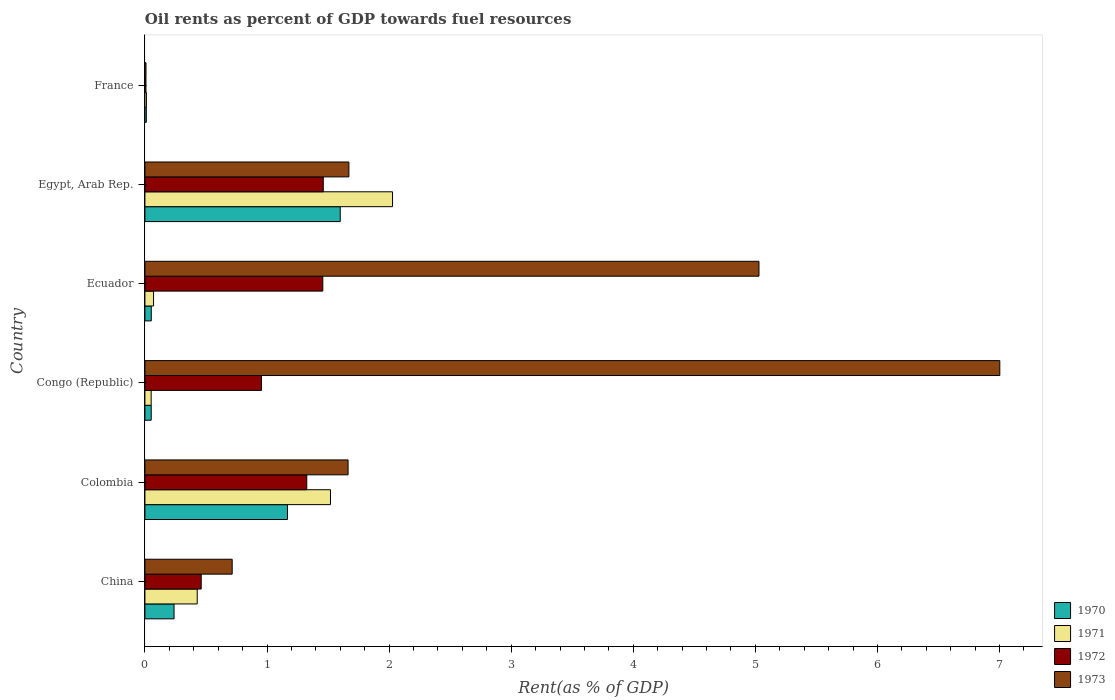How many bars are there on the 1st tick from the bottom?
Provide a short and direct response. 4. What is the oil rent in 1971 in Ecuador?
Your answer should be compact. 0.07. Across all countries, what is the maximum oil rent in 1973?
Give a very brief answer. 7. Across all countries, what is the minimum oil rent in 1970?
Offer a very short reply. 0.01. In which country was the oil rent in 1973 maximum?
Ensure brevity in your answer.  Congo (Republic). What is the total oil rent in 1971 in the graph?
Your answer should be very brief. 4.11. What is the difference between the oil rent in 1971 in China and that in France?
Provide a succinct answer. 0.42. What is the difference between the oil rent in 1972 in Egypt, Arab Rep. and the oil rent in 1973 in Ecuador?
Provide a succinct answer. -3.57. What is the average oil rent in 1972 per country?
Your response must be concise. 0.94. What is the difference between the oil rent in 1973 and oil rent in 1971 in France?
Offer a terse response. -0. In how many countries, is the oil rent in 1972 greater than 3.6 %?
Offer a very short reply. 0. What is the ratio of the oil rent in 1971 in China to that in Egypt, Arab Rep.?
Keep it short and to the point. 0.21. Is the oil rent in 1973 in China less than that in Egypt, Arab Rep.?
Offer a very short reply. Yes. Is the difference between the oil rent in 1973 in China and Egypt, Arab Rep. greater than the difference between the oil rent in 1971 in China and Egypt, Arab Rep.?
Make the answer very short. Yes. What is the difference between the highest and the second highest oil rent in 1970?
Your answer should be compact. 0.43. What is the difference between the highest and the lowest oil rent in 1971?
Your answer should be compact. 2.02. In how many countries, is the oil rent in 1970 greater than the average oil rent in 1970 taken over all countries?
Provide a succinct answer. 2. Is the sum of the oil rent in 1970 in Colombia and Ecuador greater than the maximum oil rent in 1971 across all countries?
Offer a very short reply. No. What does the 2nd bar from the top in Egypt, Arab Rep. represents?
Provide a succinct answer. 1972. What does the 4th bar from the bottom in China represents?
Offer a terse response. 1973. How many bars are there?
Give a very brief answer. 24. How many countries are there in the graph?
Provide a short and direct response. 6. What is the difference between two consecutive major ticks on the X-axis?
Your answer should be very brief. 1. Are the values on the major ticks of X-axis written in scientific E-notation?
Give a very brief answer. No. Does the graph contain any zero values?
Keep it short and to the point. No. Does the graph contain grids?
Ensure brevity in your answer.  No. Where does the legend appear in the graph?
Offer a terse response. Bottom right. How are the legend labels stacked?
Offer a very short reply. Vertical. What is the title of the graph?
Your answer should be compact. Oil rents as percent of GDP towards fuel resources. What is the label or title of the X-axis?
Keep it short and to the point. Rent(as % of GDP). What is the Rent(as % of GDP) of 1970 in China?
Your response must be concise. 0.24. What is the Rent(as % of GDP) in 1971 in China?
Ensure brevity in your answer.  0.43. What is the Rent(as % of GDP) of 1972 in China?
Offer a terse response. 0.46. What is the Rent(as % of GDP) of 1973 in China?
Make the answer very short. 0.71. What is the Rent(as % of GDP) in 1970 in Colombia?
Give a very brief answer. 1.17. What is the Rent(as % of GDP) of 1971 in Colombia?
Your answer should be very brief. 1.52. What is the Rent(as % of GDP) in 1972 in Colombia?
Your answer should be compact. 1.33. What is the Rent(as % of GDP) in 1973 in Colombia?
Offer a terse response. 1.66. What is the Rent(as % of GDP) in 1970 in Congo (Republic)?
Keep it short and to the point. 0.05. What is the Rent(as % of GDP) of 1971 in Congo (Republic)?
Give a very brief answer. 0.05. What is the Rent(as % of GDP) of 1972 in Congo (Republic)?
Give a very brief answer. 0.95. What is the Rent(as % of GDP) in 1973 in Congo (Republic)?
Your answer should be compact. 7. What is the Rent(as % of GDP) in 1970 in Ecuador?
Provide a short and direct response. 0.05. What is the Rent(as % of GDP) of 1971 in Ecuador?
Your answer should be compact. 0.07. What is the Rent(as % of GDP) in 1972 in Ecuador?
Keep it short and to the point. 1.46. What is the Rent(as % of GDP) in 1973 in Ecuador?
Make the answer very short. 5.03. What is the Rent(as % of GDP) of 1970 in Egypt, Arab Rep.?
Ensure brevity in your answer.  1.6. What is the Rent(as % of GDP) in 1971 in Egypt, Arab Rep.?
Your response must be concise. 2.03. What is the Rent(as % of GDP) of 1972 in Egypt, Arab Rep.?
Ensure brevity in your answer.  1.46. What is the Rent(as % of GDP) in 1973 in Egypt, Arab Rep.?
Keep it short and to the point. 1.67. What is the Rent(as % of GDP) in 1970 in France?
Make the answer very short. 0.01. What is the Rent(as % of GDP) of 1971 in France?
Your answer should be compact. 0.01. What is the Rent(as % of GDP) of 1972 in France?
Your answer should be very brief. 0.01. What is the Rent(as % of GDP) of 1973 in France?
Your answer should be very brief. 0.01. Across all countries, what is the maximum Rent(as % of GDP) of 1970?
Offer a terse response. 1.6. Across all countries, what is the maximum Rent(as % of GDP) in 1971?
Offer a very short reply. 2.03. Across all countries, what is the maximum Rent(as % of GDP) in 1972?
Your answer should be compact. 1.46. Across all countries, what is the maximum Rent(as % of GDP) of 1973?
Make the answer very short. 7. Across all countries, what is the minimum Rent(as % of GDP) in 1970?
Give a very brief answer. 0.01. Across all countries, what is the minimum Rent(as % of GDP) of 1971?
Keep it short and to the point. 0.01. Across all countries, what is the minimum Rent(as % of GDP) in 1972?
Your answer should be compact. 0.01. Across all countries, what is the minimum Rent(as % of GDP) of 1973?
Provide a succinct answer. 0.01. What is the total Rent(as % of GDP) of 1970 in the graph?
Provide a short and direct response. 3.12. What is the total Rent(as % of GDP) of 1971 in the graph?
Offer a terse response. 4.11. What is the total Rent(as % of GDP) in 1972 in the graph?
Ensure brevity in your answer.  5.67. What is the total Rent(as % of GDP) in 1973 in the graph?
Ensure brevity in your answer.  16.09. What is the difference between the Rent(as % of GDP) in 1970 in China and that in Colombia?
Provide a short and direct response. -0.93. What is the difference between the Rent(as % of GDP) of 1971 in China and that in Colombia?
Provide a succinct answer. -1.09. What is the difference between the Rent(as % of GDP) of 1972 in China and that in Colombia?
Give a very brief answer. -0.86. What is the difference between the Rent(as % of GDP) of 1973 in China and that in Colombia?
Ensure brevity in your answer.  -0.95. What is the difference between the Rent(as % of GDP) in 1970 in China and that in Congo (Republic)?
Provide a succinct answer. 0.19. What is the difference between the Rent(as % of GDP) of 1971 in China and that in Congo (Republic)?
Offer a terse response. 0.38. What is the difference between the Rent(as % of GDP) in 1972 in China and that in Congo (Republic)?
Your answer should be compact. -0.49. What is the difference between the Rent(as % of GDP) of 1973 in China and that in Congo (Republic)?
Provide a succinct answer. -6.29. What is the difference between the Rent(as % of GDP) in 1970 in China and that in Ecuador?
Give a very brief answer. 0.19. What is the difference between the Rent(as % of GDP) in 1971 in China and that in Ecuador?
Keep it short and to the point. 0.36. What is the difference between the Rent(as % of GDP) of 1972 in China and that in Ecuador?
Keep it short and to the point. -1. What is the difference between the Rent(as % of GDP) in 1973 in China and that in Ecuador?
Make the answer very short. -4.31. What is the difference between the Rent(as % of GDP) in 1970 in China and that in Egypt, Arab Rep.?
Your answer should be very brief. -1.36. What is the difference between the Rent(as % of GDP) in 1971 in China and that in Egypt, Arab Rep.?
Your response must be concise. -1.6. What is the difference between the Rent(as % of GDP) of 1972 in China and that in Egypt, Arab Rep.?
Your answer should be very brief. -1. What is the difference between the Rent(as % of GDP) of 1973 in China and that in Egypt, Arab Rep.?
Your answer should be compact. -0.96. What is the difference between the Rent(as % of GDP) in 1970 in China and that in France?
Give a very brief answer. 0.23. What is the difference between the Rent(as % of GDP) in 1971 in China and that in France?
Provide a succinct answer. 0.42. What is the difference between the Rent(as % of GDP) of 1972 in China and that in France?
Your answer should be very brief. 0.45. What is the difference between the Rent(as % of GDP) in 1973 in China and that in France?
Your answer should be compact. 0.71. What is the difference between the Rent(as % of GDP) of 1970 in Colombia and that in Congo (Republic)?
Your answer should be very brief. 1.12. What is the difference between the Rent(as % of GDP) of 1971 in Colombia and that in Congo (Republic)?
Provide a short and direct response. 1.47. What is the difference between the Rent(as % of GDP) of 1972 in Colombia and that in Congo (Republic)?
Provide a succinct answer. 0.37. What is the difference between the Rent(as % of GDP) in 1973 in Colombia and that in Congo (Republic)?
Offer a terse response. -5.34. What is the difference between the Rent(as % of GDP) of 1970 in Colombia and that in Ecuador?
Make the answer very short. 1.12. What is the difference between the Rent(as % of GDP) of 1971 in Colombia and that in Ecuador?
Give a very brief answer. 1.45. What is the difference between the Rent(as % of GDP) of 1972 in Colombia and that in Ecuador?
Offer a terse response. -0.13. What is the difference between the Rent(as % of GDP) of 1973 in Colombia and that in Ecuador?
Provide a short and direct response. -3.37. What is the difference between the Rent(as % of GDP) of 1970 in Colombia and that in Egypt, Arab Rep.?
Offer a terse response. -0.43. What is the difference between the Rent(as % of GDP) of 1971 in Colombia and that in Egypt, Arab Rep.?
Offer a terse response. -0.51. What is the difference between the Rent(as % of GDP) of 1972 in Colombia and that in Egypt, Arab Rep.?
Make the answer very short. -0.14. What is the difference between the Rent(as % of GDP) of 1973 in Colombia and that in Egypt, Arab Rep.?
Your answer should be very brief. -0.01. What is the difference between the Rent(as % of GDP) of 1970 in Colombia and that in France?
Offer a terse response. 1.16. What is the difference between the Rent(as % of GDP) of 1971 in Colombia and that in France?
Your response must be concise. 1.51. What is the difference between the Rent(as % of GDP) in 1972 in Colombia and that in France?
Offer a very short reply. 1.32. What is the difference between the Rent(as % of GDP) in 1973 in Colombia and that in France?
Make the answer very short. 1.66. What is the difference between the Rent(as % of GDP) of 1970 in Congo (Republic) and that in Ecuador?
Offer a very short reply. -0. What is the difference between the Rent(as % of GDP) in 1971 in Congo (Republic) and that in Ecuador?
Offer a very short reply. -0.02. What is the difference between the Rent(as % of GDP) of 1972 in Congo (Republic) and that in Ecuador?
Provide a succinct answer. -0.5. What is the difference between the Rent(as % of GDP) in 1973 in Congo (Republic) and that in Ecuador?
Offer a very short reply. 1.97. What is the difference between the Rent(as % of GDP) of 1970 in Congo (Republic) and that in Egypt, Arab Rep.?
Your answer should be compact. -1.55. What is the difference between the Rent(as % of GDP) of 1971 in Congo (Republic) and that in Egypt, Arab Rep.?
Your response must be concise. -1.98. What is the difference between the Rent(as % of GDP) of 1972 in Congo (Republic) and that in Egypt, Arab Rep.?
Ensure brevity in your answer.  -0.51. What is the difference between the Rent(as % of GDP) of 1973 in Congo (Republic) and that in Egypt, Arab Rep.?
Give a very brief answer. 5.33. What is the difference between the Rent(as % of GDP) of 1970 in Congo (Republic) and that in France?
Your response must be concise. 0.04. What is the difference between the Rent(as % of GDP) of 1971 in Congo (Republic) and that in France?
Your response must be concise. 0.04. What is the difference between the Rent(as % of GDP) in 1972 in Congo (Republic) and that in France?
Your response must be concise. 0.95. What is the difference between the Rent(as % of GDP) in 1973 in Congo (Republic) and that in France?
Your answer should be compact. 6.99. What is the difference between the Rent(as % of GDP) of 1970 in Ecuador and that in Egypt, Arab Rep.?
Offer a terse response. -1.55. What is the difference between the Rent(as % of GDP) of 1971 in Ecuador and that in Egypt, Arab Rep.?
Give a very brief answer. -1.96. What is the difference between the Rent(as % of GDP) of 1972 in Ecuador and that in Egypt, Arab Rep.?
Your answer should be very brief. -0. What is the difference between the Rent(as % of GDP) of 1973 in Ecuador and that in Egypt, Arab Rep.?
Provide a short and direct response. 3.36. What is the difference between the Rent(as % of GDP) of 1970 in Ecuador and that in France?
Ensure brevity in your answer.  0.04. What is the difference between the Rent(as % of GDP) in 1971 in Ecuador and that in France?
Ensure brevity in your answer.  0.06. What is the difference between the Rent(as % of GDP) in 1972 in Ecuador and that in France?
Your response must be concise. 1.45. What is the difference between the Rent(as % of GDP) in 1973 in Ecuador and that in France?
Keep it short and to the point. 5.02. What is the difference between the Rent(as % of GDP) of 1970 in Egypt, Arab Rep. and that in France?
Give a very brief answer. 1.59. What is the difference between the Rent(as % of GDP) in 1971 in Egypt, Arab Rep. and that in France?
Provide a short and direct response. 2.02. What is the difference between the Rent(as % of GDP) in 1972 in Egypt, Arab Rep. and that in France?
Ensure brevity in your answer.  1.45. What is the difference between the Rent(as % of GDP) of 1973 in Egypt, Arab Rep. and that in France?
Your answer should be very brief. 1.66. What is the difference between the Rent(as % of GDP) in 1970 in China and the Rent(as % of GDP) in 1971 in Colombia?
Your answer should be compact. -1.28. What is the difference between the Rent(as % of GDP) in 1970 in China and the Rent(as % of GDP) in 1972 in Colombia?
Your answer should be compact. -1.09. What is the difference between the Rent(as % of GDP) of 1970 in China and the Rent(as % of GDP) of 1973 in Colombia?
Provide a short and direct response. -1.43. What is the difference between the Rent(as % of GDP) of 1971 in China and the Rent(as % of GDP) of 1972 in Colombia?
Give a very brief answer. -0.9. What is the difference between the Rent(as % of GDP) of 1971 in China and the Rent(as % of GDP) of 1973 in Colombia?
Provide a succinct answer. -1.24. What is the difference between the Rent(as % of GDP) of 1972 in China and the Rent(as % of GDP) of 1973 in Colombia?
Make the answer very short. -1.2. What is the difference between the Rent(as % of GDP) of 1970 in China and the Rent(as % of GDP) of 1971 in Congo (Republic)?
Provide a short and direct response. 0.19. What is the difference between the Rent(as % of GDP) of 1970 in China and the Rent(as % of GDP) of 1972 in Congo (Republic)?
Offer a terse response. -0.72. What is the difference between the Rent(as % of GDP) of 1970 in China and the Rent(as % of GDP) of 1973 in Congo (Republic)?
Provide a short and direct response. -6.76. What is the difference between the Rent(as % of GDP) in 1971 in China and the Rent(as % of GDP) in 1972 in Congo (Republic)?
Your response must be concise. -0.53. What is the difference between the Rent(as % of GDP) of 1971 in China and the Rent(as % of GDP) of 1973 in Congo (Republic)?
Give a very brief answer. -6.57. What is the difference between the Rent(as % of GDP) of 1972 in China and the Rent(as % of GDP) of 1973 in Congo (Republic)?
Your response must be concise. -6.54. What is the difference between the Rent(as % of GDP) in 1970 in China and the Rent(as % of GDP) in 1971 in Ecuador?
Your answer should be compact. 0.17. What is the difference between the Rent(as % of GDP) in 1970 in China and the Rent(as % of GDP) in 1972 in Ecuador?
Offer a very short reply. -1.22. What is the difference between the Rent(as % of GDP) of 1970 in China and the Rent(as % of GDP) of 1973 in Ecuador?
Provide a short and direct response. -4.79. What is the difference between the Rent(as % of GDP) in 1971 in China and the Rent(as % of GDP) in 1972 in Ecuador?
Keep it short and to the point. -1.03. What is the difference between the Rent(as % of GDP) of 1971 in China and the Rent(as % of GDP) of 1973 in Ecuador?
Offer a very short reply. -4.6. What is the difference between the Rent(as % of GDP) of 1972 in China and the Rent(as % of GDP) of 1973 in Ecuador?
Your answer should be very brief. -4.57. What is the difference between the Rent(as % of GDP) in 1970 in China and the Rent(as % of GDP) in 1971 in Egypt, Arab Rep.?
Offer a very short reply. -1.79. What is the difference between the Rent(as % of GDP) of 1970 in China and the Rent(as % of GDP) of 1972 in Egypt, Arab Rep.?
Offer a terse response. -1.22. What is the difference between the Rent(as % of GDP) in 1970 in China and the Rent(as % of GDP) in 1973 in Egypt, Arab Rep.?
Your answer should be compact. -1.43. What is the difference between the Rent(as % of GDP) of 1971 in China and the Rent(as % of GDP) of 1972 in Egypt, Arab Rep.?
Your answer should be compact. -1.03. What is the difference between the Rent(as % of GDP) of 1971 in China and the Rent(as % of GDP) of 1973 in Egypt, Arab Rep.?
Offer a terse response. -1.24. What is the difference between the Rent(as % of GDP) of 1972 in China and the Rent(as % of GDP) of 1973 in Egypt, Arab Rep.?
Make the answer very short. -1.21. What is the difference between the Rent(as % of GDP) in 1970 in China and the Rent(as % of GDP) in 1971 in France?
Provide a short and direct response. 0.23. What is the difference between the Rent(as % of GDP) in 1970 in China and the Rent(as % of GDP) in 1972 in France?
Provide a short and direct response. 0.23. What is the difference between the Rent(as % of GDP) in 1970 in China and the Rent(as % of GDP) in 1973 in France?
Your response must be concise. 0.23. What is the difference between the Rent(as % of GDP) of 1971 in China and the Rent(as % of GDP) of 1972 in France?
Your response must be concise. 0.42. What is the difference between the Rent(as % of GDP) in 1971 in China and the Rent(as % of GDP) in 1973 in France?
Give a very brief answer. 0.42. What is the difference between the Rent(as % of GDP) in 1972 in China and the Rent(as % of GDP) in 1973 in France?
Provide a succinct answer. 0.45. What is the difference between the Rent(as % of GDP) in 1970 in Colombia and the Rent(as % of GDP) in 1971 in Congo (Republic)?
Keep it short and to the point. 1.12. What is the difference between the Rent(as % of GDP) of 1970 in Colombia and the Rent(as % of GDP) of 1972 in Congo (Republic)?
Provide a short and direct response. 0.21. What is the difference between the Rent(as % of GDP) of 1970 in Colombia and the Rent(as % of GDP) of 1973 in Congo (Republic)?
Ensure brevity in your answer.  -5.83. What is the difference between the Rent(as % of GDP) of 1971 in Colombia and the Rent(as % of GDP) of 1972 in Congo (Republic)?
Your answer should be very brief. 0.57. What is the difference between the Rent(as % of GDP) of 1971 in Colombia and the Rent(as % of GDP) of 1973 in Congo (Republic)?
Provide a short and direct response. -5.48. What is the difference between the Rent(as % of GDP) in 1972 in Colombia and the Rent(as % of GDP) in 1973 in Congo (Republic)?
Your response must be concise. -5.68. What is the difference between the Rent(as % of GDP) in 1970 in Colombia and the Rent(as % of GDP) in 1971 in Ecuador?
Give a very brief answer. 1.1. What is the difference between the Rent(as % of GDP) of 1970 in Colombia and the Rent(as % of GDP) of 1972 in Ecuador?
Make the answer very short. -0.29. What is the difference between the Rent(as % of GDP) in 1970 in Colombia and the Rent(as % of GDP) in 1973 in Ecuador?
Provide a short and direct response. -3.86. What is the difference between the Rent(as % of GDP) in 1971 in Colombia and the Rent(as % of GDP) in 1972 in Ecuador?
Your response must be concise. 0.06. What is the difference between the Rent(as % of GDP) of 1971 in Colombia and the Rent(as % of GDP) of 1973 in Ecuador?
Offer a terse response. -3.51. What is the difference between the Rent(as % of GDP) in 1972 in Colombia and the Rent(as % of GDP) in 1973 in Ecuador?
Your answer should be very brief. -3.7. What is the difference between the Rent(as % of GDP) of 1970 in Colombia and the Rent(as % of GDP) of 1971 in Egypt, Arab Rep.?
Your response must be concise. -0.86. What is the difference between the Rent(as % of GDP) in 1970 in Colombia and the Rent(as % of GDP) in 1972 in Egypt, Arab Rep.?
Give a very brief answer. -0.29. What is the difference between the Rent(as % of GDP) of 1970 in Colombia and the Rent(as % of GDP) of 1973 in Egypt, Arab Rep.?
Provide a short and direct response. -0.5. What is the difference between the Rent(as % of GDP) in 1971 in Colombia and the Rent(as % of GDP) in 1972 in Egypt, Arab Rep.?
Give a very brief answer. 0.06. What is the difference between the Rent(as % of GDP) of 1971 in Colombia and the Rent(as % of GDP) of 1973 in Egypt, Arab Rep.?
Your answer should be compact. -0.15. What is the difference between the Rent(as % of GDP) in 1972 in Colombia and the Rent(as % of GDP) in 1973 in Egypt, Arab Rep.?
Your answer should be compact. -0.34. What is the difference between the Rent(as % of GDP) of 1970 in Colombia and the Rent(as % of GDP) of 1971 in France?
Offer a terse response. 1.16. What is the difference between the Rent(as % of GDP) in 1970 in Colombia and the Rent(as % of GDP) in 1972 in France?
Make the answer very short. 1.16. What is the difference between the Rent(as % of GDP) of 1970 in Colombia and the Rent(as % of GDP) of 1973 in France?
Your response must be concise. 1.16. What is the difference between the Rent(as % of GDP) in 1971 in Colombia and the Rent(as % of GDP) in 1972 in France?
Your answer should be very brief. 1.51. What is the difference between the Rent(as % of GDP) of 1971 in Colombia and the Rent(as % of GDP) of 1973 in France?
Offer a terse response. 1.51. What is the difference between the Rent(as % of GDP) of 1972 in Colombia and the Rent(as % of GDP) of 1973 in France?
Give a very brief answer. 1.32. What is the difference between the Rent(as % of GDP) of 1970 in Congo (Republic) and the Rent(as % of GDP) of 1971 in Ecuador?
Provide a short and direct response. -0.02. What is the difference between the Rent(as % of GDP) in 1970 in Congo (Republic) and the Rent(as % of GDP) in 1972 in Ecuador?
Offer a terse response. -1.41. What is the difference between the Rent(as % of GDP) in 1970 in Congo (Republic) and the Rent(as % of GDP) in 1973 in Ecuador?
Provide a short and direct response. -4.98. What is the difference between the Rent(as % of GDP) in 1971 in Congo (Republic) and the Rent(as % of GDP) in 1972 in Ecuador?
Keep it short and to the point. -1.41. What is the difference between the Rent(as % of GDP) in 1971 in Congo (Republic) and the Rent(as % of GDP) in 1973 in Ecuador?
Make the answer very short. -4.98. What is the difference between the Rent(as % of GDP) of 1972 in Congo (Republic) and the Rent(as % of GDP) of 1973 in Ecuador?
Provide a short and direct response. -4.08. What is the difference between the Rent(as % of GDP) of 1970 in Congo (Republic) and the Rent(as % of GDP) of 1971 in Egypt, Arab Rep.?
Offer a very short reply. -1.98. What is the difference between the Rent(as % of GDP) in 1970 in Congo (Republic) and the Rent(as % of GDP) in 1972 in Egypt, Arab Rep.?
Provide a short and direct response. -1.41. What is the difference between the Rent(as % of GDP) of 1970 in Congo (Republic) and the Rent(as % of GDP) of 1973 in Egypt, Arab Rep.?
Ensure brevity in your answer.  -1.62. What is the difference between the Rent(as % of GDP) in 1971 in Congo (Republic) and the Rent(as % of GDP) in 1972 in Egypt, Arab Rep.?
Your answer should be compact. -1.41. What is the difference between the Rent(as % of GDP) in 1971 in Congo (Republic) and the Rent(as % of GDP) in 1973 in Egypt, Arab Rep.?
Your answer should be very brief. -1.62. What is the difference between the Rent(as % of GDP) in 1972 in Congo (Republic) and the Rent(as % of GDP) in 1973 in Egypt, Arab Rep.?
Your answer should be compact. -0.72. What is the difference between the Rent(as % of GDP) in 1970 in Congo (Republic) and the Rent(as % of GDP) in 1971 in France?
Give a very brief answer. 0.04. What is the difference between the Rent(as % of GDP) of 1970 in Congo (Republic) and the Rent(as % of GDP) of 1972 in France?
Make the answer very short. 0.04. What is the difference between the Rent(as % of GDP) in 1970 in Congo (Republic) and the Rent(as % of GDP) in 1973 in France?
Keep it short and to the point. 0.04. What is the difference between the Rent(as % of GDP) in 1971 in Congo (Republic) and the Rent(as % of GDP) in 1972 in France?
Offer a terse response. 0.04. What is the difference between the Rent(as % of GDP) of 1971 in Congo (Republic) and the Rent(as % of GDP) of 1973 in France?
Offer a terse response. 0.04. What is the difference between the Rent(as % of GDP) in 1972 in Congo (Republic) and the Rent(as % of GDP) in 1973 in France?
Keep it short and to the point. 0.95. What is the difference between the Rent(as % of GDP) in 1970 in Ecuador and the Rent(as % of GDP) in 1971 in Egypt, Arab Rep.?
Give a very brief answer. -1.98. What is the difference between the Rent(as % of GDP) of 1970 in Ecuador and the Rent(as % of GDP) of 1972 in Egypt, Arab Rep.?
Offer a terse response. -1.41. What is the difference between the Rent(as % of GDP) of 1970 in Ecuador and the Rent(as % of GDP) of 1973 in Egypt, Arab Rep.?
Offer a very short reply. -1.62. What is the difference between the Rent(as % of GDP) of 1971 in Ecuador and the Rent(as % of GDP) of 1972 in Egypt, Arab Rep.?
Offer a very short reply. -1.39. What is the difference between the Rent(as % of GDP) of 1971 in Ecuador and the Rent(as % of GDP) of 1973 in Egypt, Arab Rep.?
Provide a short and direct response. -1.6. What is the difference between the Rent(as % of GDP) of 1972 in Ecuador and the Rent(as % of GDP) of 1973 in Egypt, Arab Rep.?
Offer a terse response. -0.21. What is the difference between the Rent(as % of GDP) of 1970 in Ecuador and the Rent(as % of GDP) of 1971 in France?
Give a very brief answer. 0.04. What is the difference between the Rent(as % of GDP) of 1970 in Ecuador and the Rent(as % of GDP) of 1972 in France?
Ensure brevity in your answer.  0.04. What is the difference between the Rent(as % of GDP) in 1970 in Ecuador and the Rent(as % of GDP) in 1973 in France?
Offer a terse response. 0.04. What is the difference between the Rent(as % of GDP) in 1971 in Ecuador and the Rent(as % of GDP) in 1972 in France?
Ensure brevity in your answer.  0.06. What is the difference between the Rent(as % of GDP) of 1971 in Ecuador and the Rent(as % of GDP) of 1973 in France?
Ensure brevity in your answer.  0.06. What is the difference between the Rent(as % of GDP) of 1972 in Ecuador and the Rent(as % of GDP) of 1973 in France?
Offer a very short reply. 1.45. What is the difference between the Rent(as % of GDP) of 1970 in Egypt, Arab Rep. and the Rent(as % of GDP) of 1971 in France?
Keep it short and to the point. 1.59. What is the difference between the Rent(as % of GDP) in 1970 in Egypt, Arab Rep. and the Rent(as % of GDP) in 1972 in France?
Offer a terse response. 1.59. What is the difference between the Rent(as % of GDP) in 1970 in Egypt, Arab Rep. and the Rent(as % of GDP) in 1973 in France?
Your answer should be compact. 1.59. What is the difference between the Rent(as % of GDP) in 1971 in Egypt, Arab Rep. and the Rent(as % of GDP) in 1972 in France?
Keep it short and to the point. 2.02. What is the difference between the Rent(as % of GDP) in 1971 in Egypt, Arab Rep. and the Rent(as % of GDP) in 1973 in France?
Give a very brief answer. 2.02. What is the difference between the Rent(as % of GDP) in 1972 in Egypt, Arab Rep. and the Rent(as % of GDP) in 1973 in France?
Offer a very short reply. 1.45. What is the average Rent(as % of GDP) in 1970 per country?
Offer a terse response. 0.52. What is the average Rent(as % of GDP) in 1971 per country?
Your answer should be compact. 0.69. What is the average Rent(as % of GDP) of 1972 per country?
Offer a terse response. 0.94. What is the average Rent(as % of GDP) of 1973 per country?
Your answer should be very brief. 2.68. What is the difference between the Rent(as % of GDP) in 1970 and Rent(as % of GDP) in 1971 in China?
Give a very brief answer. -0.19. What is the difference between the Rent(as % of GDP) of 1970 and Rent(as % of GDP) of 1972 in China?
Make the answer very short. -0.22. What is the difference between the Rent(as % of GDP) in 1970 and Rent(as % of GDP) in 1973 in China?
Provide a succinct answer. -0.48. What is the difference between the Rent(as % of GDP) in 1971 and Rent(as % of GDP) in 1972 in China?
Make the answer very short. -0.03. What is the difference between the Rent(as % of GDP) of 1971 and Rent(as % of GDP) of 1973 in China?
Ensure brevity in your answer.  -0.29. What is the difference between the Rent(as % of GDP) of 1972 and Rent(as % of GDP) of 1973 in China?
Your answer should be very brief. -0.25. What is the difference between the Rent(as % of GDP) in 1970 and Rent(as % of GDP) in 1971 in Colombia?
Ensure brevity in your answer.  -0.35. What is the difference between the Rent(as % of GDP) in 1970 and Rent(as % of GDP) in 1972 in Colombia?
Offer a very short reply. -0.16. What is the difference between the Rent(as % of GDP) of 1970 and Rent(as % of GDP) of 1973 in Colombia?
Provide a short and direct response. -0.5. What is the difference between the Rent(as % of GDP) of 1971 and Rent(as % of GDP) of 1972 in Colombia?
Offer a very short reply. 0.19. What is the difference between the Rent(as % of GDP) in 1971 and Rent(as % of GDP) in 1973 in Colombia?
Provide a short and direct response. -0.14. What is the difference between the Rent(as % of GDP) in 1972 and Rent(as % of GDP) in 1973 in Colombia?
Offer a terse response. -0.34. What is the difference between the Rent(as % of GDP) in 1970 and Rent(as % of GDP) in 1971 in Congo (Republic)?
Your answer should be compact. 0. What is the difference between the Rent(as % of GDP) in 1970 and Rent(as % of GDP) in 1972 in Congo (Republic)?
Ensure brevity in your answer.  -0.9. What is the difference between the Rent(as % of GDP) in 1970 and Rent(as % of GDP) in 1973 in Congo (Republic)?
Your response must be concise. -6.95. What is the difference between the Rent(as % of GDP) of 1971 and Rent(as % of GDP) of 1972 in Congo (Republic)?
Provide a succinct answer. -0.9. What is the difference between the Rent(as % of GDP) in 1971 and Rent(as % of GDP) in 1973 in Congo (Republic)?
Provide a succinct answer. -6.95. What is the difference between the Rent(as % of GDP) of 1972 and Rent(as % of GDP) of 1973 in Congo (Republic)?
Ensure brevity in your answer.  -6.05. What is the difference between the Rent(as % of GDP) in 1970 and Rent(as % of GDP) in 1971 in Ecuador?
Offer a very short reply. -0.02. What is the difference between the Rent(as % of GDP) of 1970 and Rent(as % of GDP) of 1972 in Ecuador?
Provide a short and direct response. -1.41. What is the difference between the Rent(as % of GDP) of 1970 and Rent(as % of GDP) of 1973 in Ecuador?
Your answer should be very brief. -4.98. What is the difference between the Rent(as % of GDP) in 1971 and Rent(as % of GDP) in 1972 in Ecuador?
Your answer should be very brief. -1.39. What is the difference between the Rent(as % of GDP) in 1971 and Rent(as % of GDP) in 1973 in Ecuador?
Your response must be concise. -4.96. What is the difference between the Rent(as % of GDP) of 1972 and Rent(as % of GDP) of 1973 in Ecuador?
Provide a succinct answer. -3.57. What is the difference between the Rent(as % of GDP) of 1970 and Rent(as % of GDP) of 1971 in Egypt, Arab Rep.?
Give a very brief answer. -0.43. What is the difference between the Rent(as % of GDP) of 1970 and Rent(as % of GDP) of 1972 in Egypt, Arab Rep.?
Offer a very short reply. 0.14. What is the difference between the Rent(as % of GDP) in 1970 and Rent(as % of GDP) in 1973 in Egypt, Arab Rep.?
Provide a short and direct response. -0.07. What is the difference between the Rent(as % of GDP) of 1971 and Rent(as % of GDP) of 1972 in Egypt, Arab Rep.?
Offer a terse response. 0.57. What is the difference between the Rent(as % of GDP) in 1971 and Rent(as % of GDP) in 1973 in Egypt, Arab Rep.?
Your answer should be very brief. 0.36. What is the difference between the Rent(as % of GDP) in 1972 and Rent(as % of GDP) in 1973 in Egypt, Arab Rep.?
Your answer should be compact. -0.21. What is the difference between the Rent(as % of GDP) of 1970 and Rent(as % of GDP) of 1971 in France?
Give a very brief answer. -0. What is the difference between the Rent(as % of GDP) of 1970 and Rent(as % of GDP) of 1972 in France?
Provide a short and direct response. 0. What is the difference between the Rent(as % of GDP) of 1970 and Rent(as % of GDP) of 1973 in France?
Provide a succinct answer. 0. What is the difference between the Rent(as % of GDP) of 1971 and Rent(as % of GDP) of 1972 in France?
Ensure brevity in your answer.  0. What is the difference between the Rent(as % of GDP) in 1971 and Rent(as % of GDP) in 1973 in France?
Your answer should be very brief. 0. What is the difference between the Rent(as % of GDP) of 1972 and Rent(as % of GDP) of 1973 in France?
Your answer should be very brief. -0. What is the ratio of the Rent(as % of GDP) in 1970 in China to that in Colombia?
Make the answer very short. 0.2. What is the ratio of the Rent(as % of GDP) in 1971 in China to that in Colombia?
Keep it short and to the point. 0.28. What is the ratio of the Rent(as % of GDP) in 1972 in China to that in Colombia?
Your response must be concise. 0.35. What is the ratio of the Rent(as % of GDP) of 1973 in China to that in Colombia?
Your answer should be compact. 0.43. What is the ratio of the Rent(as % of GDP) of 1970 in China to that in Congo (Republic)?
Keep it short and to the point. 4.62. What is the ratio of the Rent(as % of GDP) of 1971 in China to that in Congo (Republic)?
Offer a terse response. 8.4. What is the ratio of the Rent(as % of GDP) of 1972 in China to that in Congo (Republic)?
Keep it short and to the point. 0.48. What is the ratio of the Rent(as % of GDP) in 1973 in China to that in Congo (Republic)?
Your answer should be very brief. 0.1. What is the ratio of the Rent(as % of GDP) in 1970 in China to that in Ecuador?
Make the answer very short. 4.59. What is the ratio of the Rent(as % of GDP) in 1971 in China to that in Ecuador?
Ensure brevity in your answer.  6.05. What is the ratio of the Rent(as % of GDP) in 1972 in China to that in Ecuador?
Your answer should be compact. 0.32. What is the ratio of the Rent(as % of GDP) of 1973 in China to that in Ecuador?
Ensure brevity in your answer.  0.14. What is the ratio of the Rent(as % of GDP) of 1970 in China to that in Egypt, Arab Rep.?
Make the answer very short. 0.15. What is the ratio of the Rent(as % of GDP) of 1971 in China to that in Egypt, Arab Rep.?
Ensure brevity in your answer.  0.21. What is the ratio of the Rent(as % of GDP) of 1972 in China to that in Egypt, Arab Rep.?
Ensure brevity in your answer.  0.32. What is the ratio of the Rent(as % of GDP) of 1973 in China to that in Egypt, Arab Rep.?
Provide a short and direct response. 0.43. What is the ratio of the Rent(as % of GDP) in 1970 in China to that in France?
Your answer should be compact. 20.74. What is the ratio of the Rent(as % of GDP) in 1971 in China to that in France?
Offer a very short reply. 34.74. What is the ratio of the Rent(as % of GDP) in 1972 in China to that in France?
Give a very brief answer. 54.26. What is the ratio of the Rent(as % of GDP) in 1973 in China to that in France?
Give a very brief answer. 80.88. What is the ratio of the Rent(as % of GDP) in 1970 in Colombia to that in Congo (Republic)?
Your answer should be compact. 22.61. What is the ratio of the Rent(as % of GDP) of 1971 in Colombia to that in Congo (Republic)?
Keep it short and to the point. 29.79. What is the ratio of the Rent(as % of GDP) in 1972 in Colombia to that in Congo (Republic)?
Your answer should be very brief. 1.39. What is the ratio of the Rent(as % of GDP) of 1973 in Colombia to that in Congo (Republic)?
Keep it short and to the point. 0.24. What is the ratio of the Rent(as % of GDP) of 1970 in Colombia to that in Ecuador?
Your answer should be compact. 22.47. What is the ratio of the Rent(as % of GDP) in 1971 in Colombia to that in Ecuador?
Provide a succinct answer. 21.47. What is the ratio of the Rent(as % of GDP) in 1972 in Colombia to that in Ecuador?
Offer a very short reply. 0.91. What is the ratio of the Rent(as % of GDP) in 1973 in Colombia to that in Ecuador?
Keep it short and to the point. 0.33. What is the ratio of the Rent(as % of GDP) in 1970 in Colombia to that in Egypt, Arab Rep.?
Make the answer very short. 0.73. What is the ratio of the Rent(as % of GDP) in 1971 in Colombia to that in Egypt, Arab Rep.?
Provide a succinct answer. 0.75. What is the ratio of the Rent(as % of GDP) in 1972 in Colombia to that in Egypt, Arab Rep.?
Keep it short and to the point. 0.91. What is the ratio of the Rent(as % of GDP) in 1973 in Colombia to that in Egypt, Arab Rep.?
Offer a very short reply. 1. What is the ratio of the Rent(as % of GDP) in 1970 in Colombia to that in France?
Ensure brevity in your answer.  101.51. What is the ratio of the Rent(as % of GDP) of 1971 in Colombia to that in France?
Ensure brevity in your answer.  123.21. What is the ratio of the Rent(as % of GDP) in 1972 in Colombia to that in France?
Your answer should be compact. 156.02. What is the ratio of the Rent(as % of GDP) of 1973 in Colombia to that in France?
Provide a succinct answer. 188.27. What is the ratio of the Rent(as % of GDP) in 1971 in Congo (Republic) to that in Ecuador?
Offer a very short reply. 0.72. What is the ratio of the Rent(as % of GDP) of 1972 in Congo (Republic) to that in Ecuador?
Your answer should be compact. 0.65. What is the ratio of the Rent(as % of GDP) in 1973 in Congo (Republic) to that in Ecuador?
Provide a short and direct response. 1.39. What is the ratio of the Rent(as % of GDP) of 1970 in Congo (Republic) to that in Egypt, Arab Rep.?
Give a very brief answer. 0.03. What is the ratio of the Rent(as % of GDP) in 1971 in Congo (Republic) to that in Egypt, Arab Rep.?
Your answer should be very brief. 0.03. What is the ratio of the Rent(as % of GDP) in 1972 in Congo (Republic) to that in Egypt, Arab Rep.?
Your answer should be very brief. 0.65. What is the ratio of the Rent(as % of GDP) in 1973 in Congo (Republic) to that in Egypt, Arab Rep.?
Keep it short and to the point. 4.19. What is the ratio of the Rent(as % of GDP) in 1970 in Congo (Republic) to that in France?
Your answer should be compact. 4.49. What is the ratio of the Rent(as % of GDP) of 1971 in Congo (Republic) to that in France?
Your response must be concise. 4.14. What is the ratio of the Rent(as % of GDP) in 1972 in Congo (Republic) to that in France?
Your answer should be very brief. 112.31. What is the ratio of the Rent(as % of GDP) in 1973 in Congo (Republic) to that in France?
Ensure brevity in your answer.  792.27. What is the ratio of the Rent(as % of GDP) in 1970 in Ecuador to that in Egypt, Arab Rep.?
Your response must be concise. 0.03. What is the ratio of the Rent(as % of GDP) in 1971 in Ecuador to that in Egypt, Arab Rep.?
Offer a terse response. 0.03. What is the ratio of the Rent(as % of GDP) in 1972 in Ecuador to that in Egypt, Arab Rep.?
Keep it short and to the point. 1. What is the ratio of the Rent(as % of GDP) in 1973 in Ecuador to that in Egypt, Arab Rep.?
Offer a very short reply. 3.01. What is the ratio of the Rent(as % of GDP) of 1970 in Ecuador to that in France?
Ensure brevity in your answer.  4.52. What is the ratio of the Rent(as % of GDP) of 1971 in Ecuador to that in France?
Your answer should be compact. 5.74. What is the ratio of the Rent(as % of GDP) in 1972 in Ecuador to that in France?
Ensure brevity in your answer.  171.48. What is the ratio of the Rent(as % of GDP) of 1973 in Ecuador to that in France?
Make the answer very short. 569.07. What is the ratio of the Rent(as % of GDP) in 1970 in Egypt, Arab Rep. to that in France?
Offer a terse response. 139.1. What is the ratio of the Rent(as % of GDP) in 1971 in Egypt, Arab Rep. to that in France?
Keep it short and to the point. 164.4. What is the ratio of the Rent(as % of GDP) in 1972 in Egypt, Arab Rep. to that in France?
Keep it short and to the point. 171.93. What is the ratio of the Rent(as % of GDP) in 1973 in Egypt, Arab Rep. to that in France?
Your answer should be compact. 189.03. What is the difference between the highest and the second highest Rent(as % of GDP) in 1970?
Your answer should be very brief. 0.43. What is the difference between the highest and the second highest Rent(as % of GDP) of 1971?
Offer a terse response. 0.51. What is the difference between the highest and the second highest Rent(as % of GDP) in 1972?
Your response must be concise. 0. What is the difference between the highest and the second highest Rent(as % of GDP) in 1973?
Offer a very short reply. 1.97. What is the difference between the highest and the lowest Rent(as % of GDP) of 1970?
Give a very brief answer. 1.59. What is the difference between the highest and the lowest Rent(as % of GDP) of 1971?
Provide a succinct answer. 2.02. What is the difference between the highest and the lowest Rent(as % of GDP) of 1972?
Offer a very short reply. 1.45. What is the difference between the highest and the lowest Rent(as % of GDP) of 1973?
Your answer should be very brief. 6.99. 